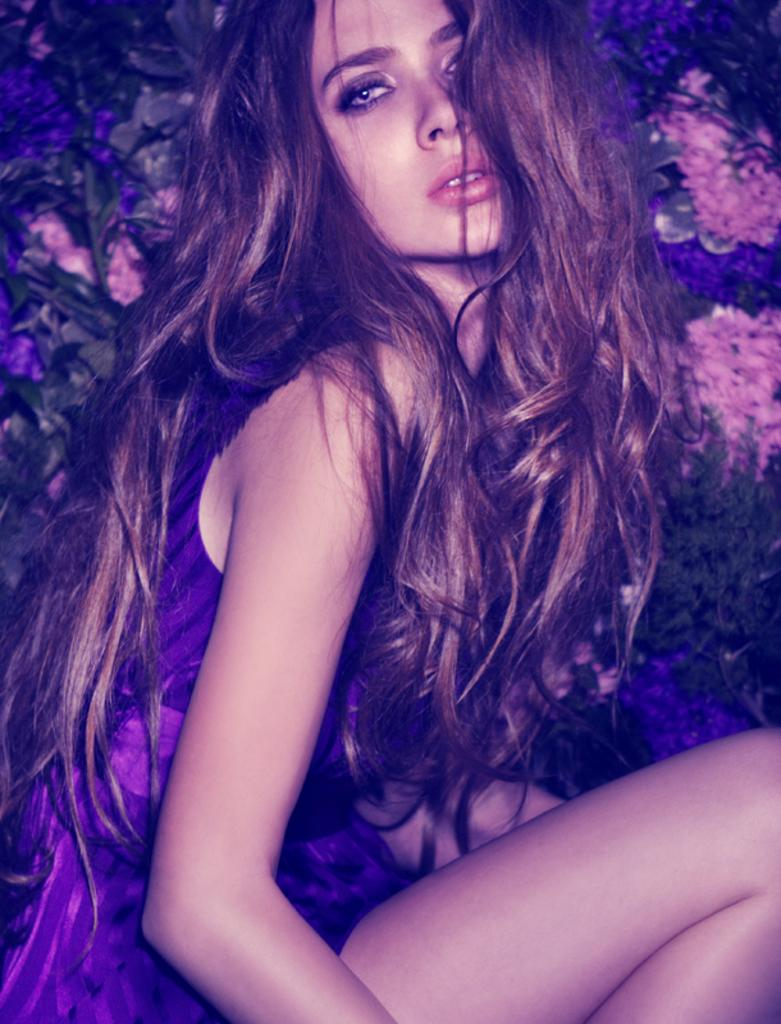Who is present in the image? There is a woman in the image. What can be seen in the background of the image? There are flowers and leaves in the background of the image. What type of drink is the woman holding in the image? There is no drink visible in the image; the woman is not holding anything. 